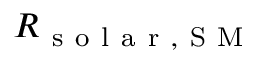Convert formula to latex. <formula><loc_0><loc_0><loc_500><loc_500>R _ { s o l a r , S M }</formula> 